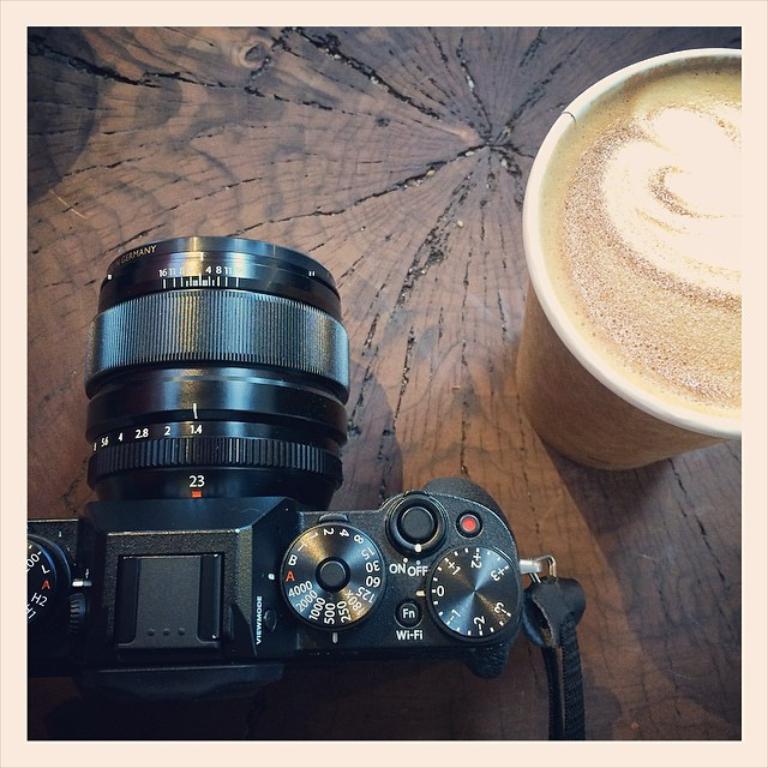Please provide a concise description of this image. This image consists of a camera at the left bottom. In the right to, a coffee glass which is kept on the table. This image is taken inside a room. 